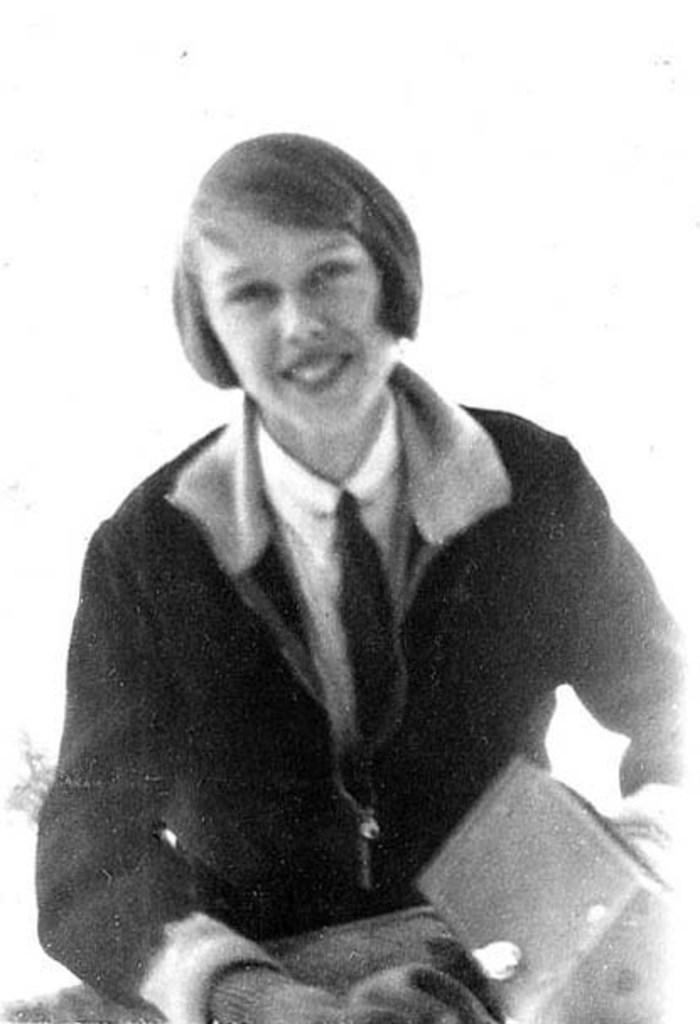Can you describe this image briefly? This is a black and white picture. The girl in white shirt and black jacket is holding a box in her hand and she is smiling. In the background, it is white in color. 